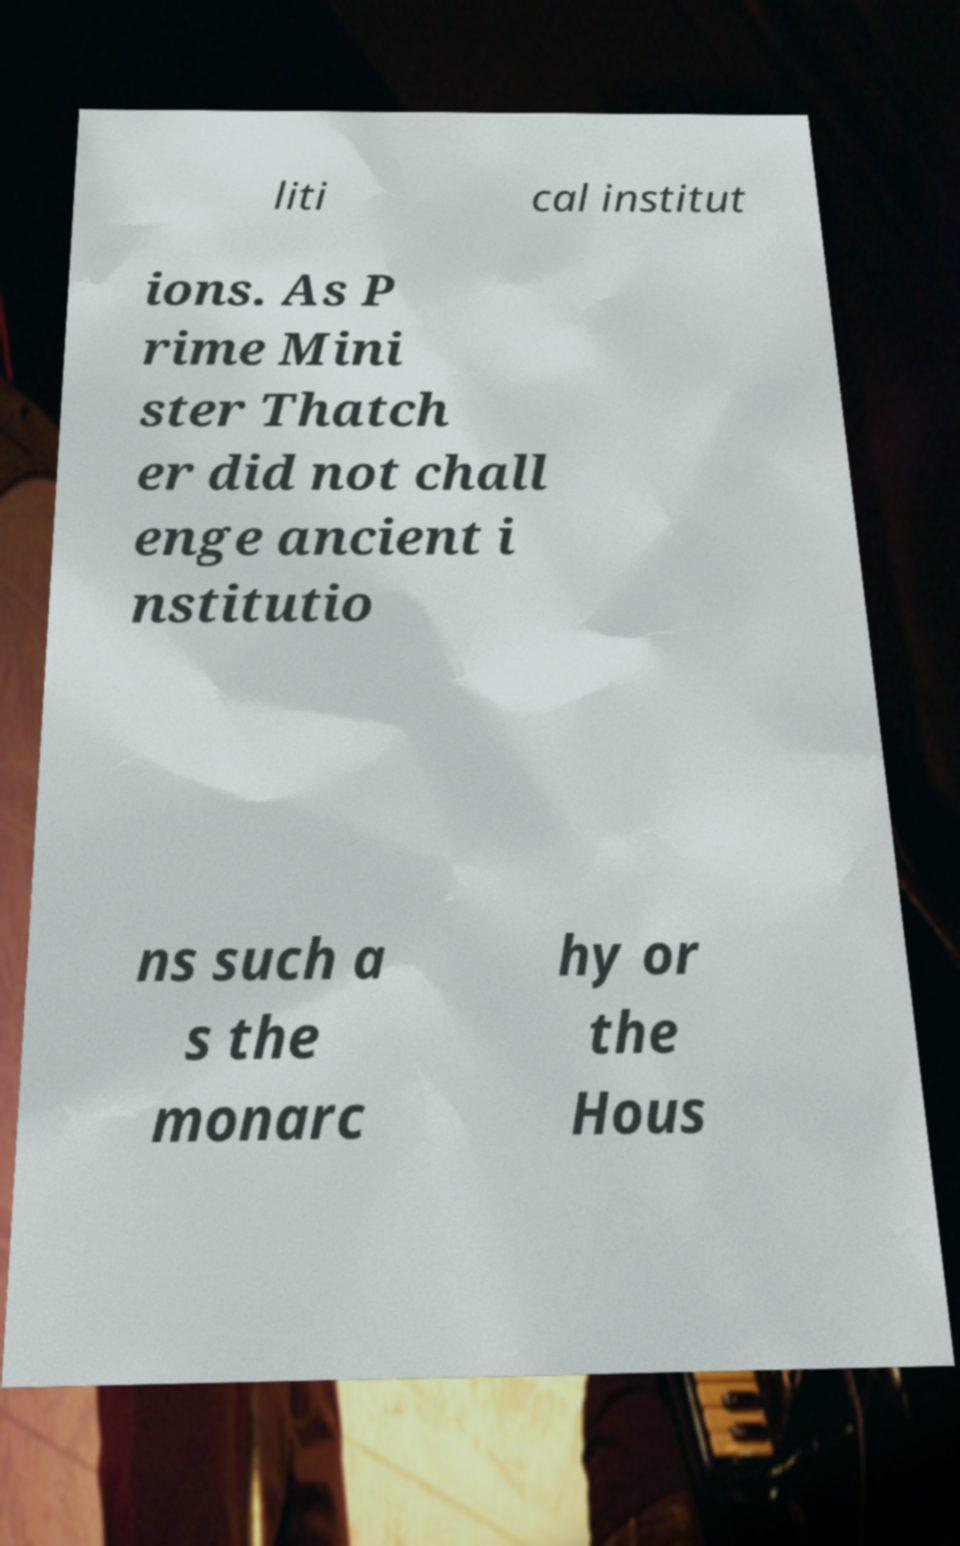For documentation purposes, I need the text within this image transcribed. Could you provide that? liti cal institut ions. As P rime Mini ster Thatch er did not chall enge ancient i nstitutio ns such a s the monarc hy or the Hous 